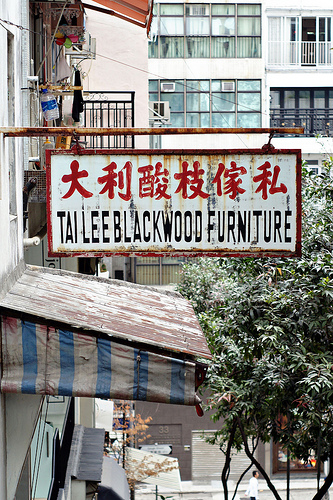<image>
Is the sign in front of the building? Yes. The sign is positioned in front of the building, appearing closer to the camera viewpoint. 